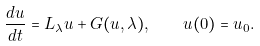Convert formula to latex. <formula><loc_0><loc_0><loc_500><loc_500>\frac { d u } { d t } = L _ { \lambda } u + G ( u , \lambda ) , \quad u ( 0 ) = u _ { 0 } .</formula> 